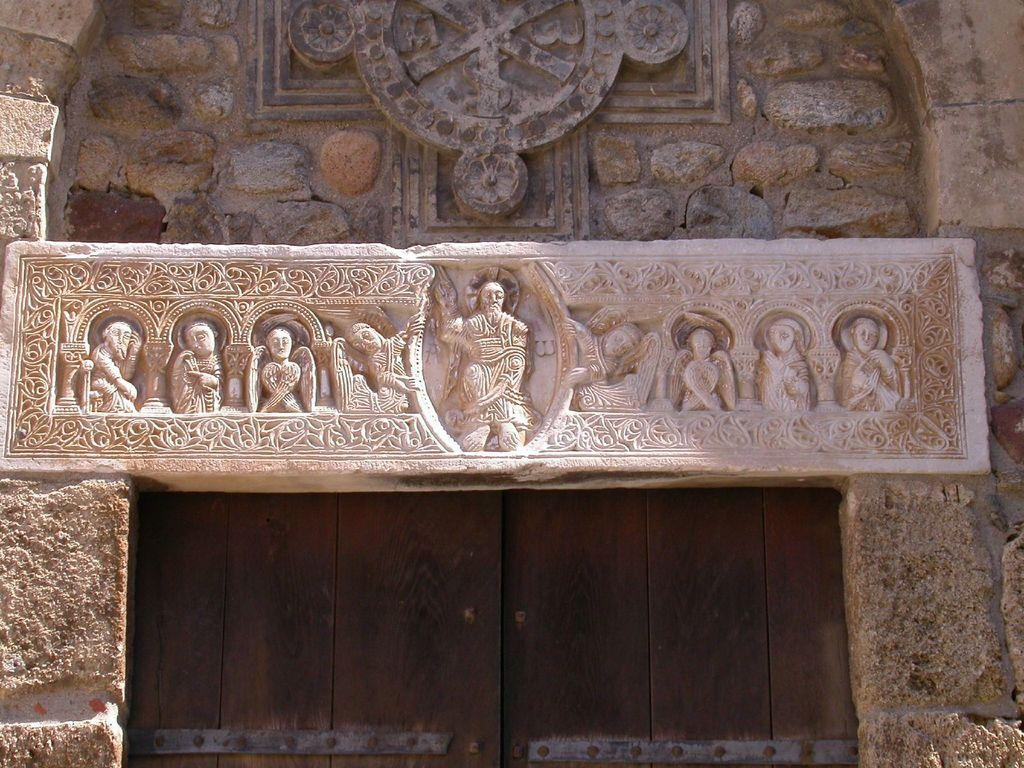What architectural feature is the main subject of the image? There is an arch of a building in the image. What is the color of the arch? The arch is in cream color. What other element can be seen in the background of the image? There is a door in the background of the image. What is the color of the door? The door is in brown color. What type of time-measuring apparatus is visible in the image? There is no time-measuring apparatus present in the image. What things are being used to create the arch in the image? The image does not show the process of creating the arch or the materials used; it only shows the completed arch. 